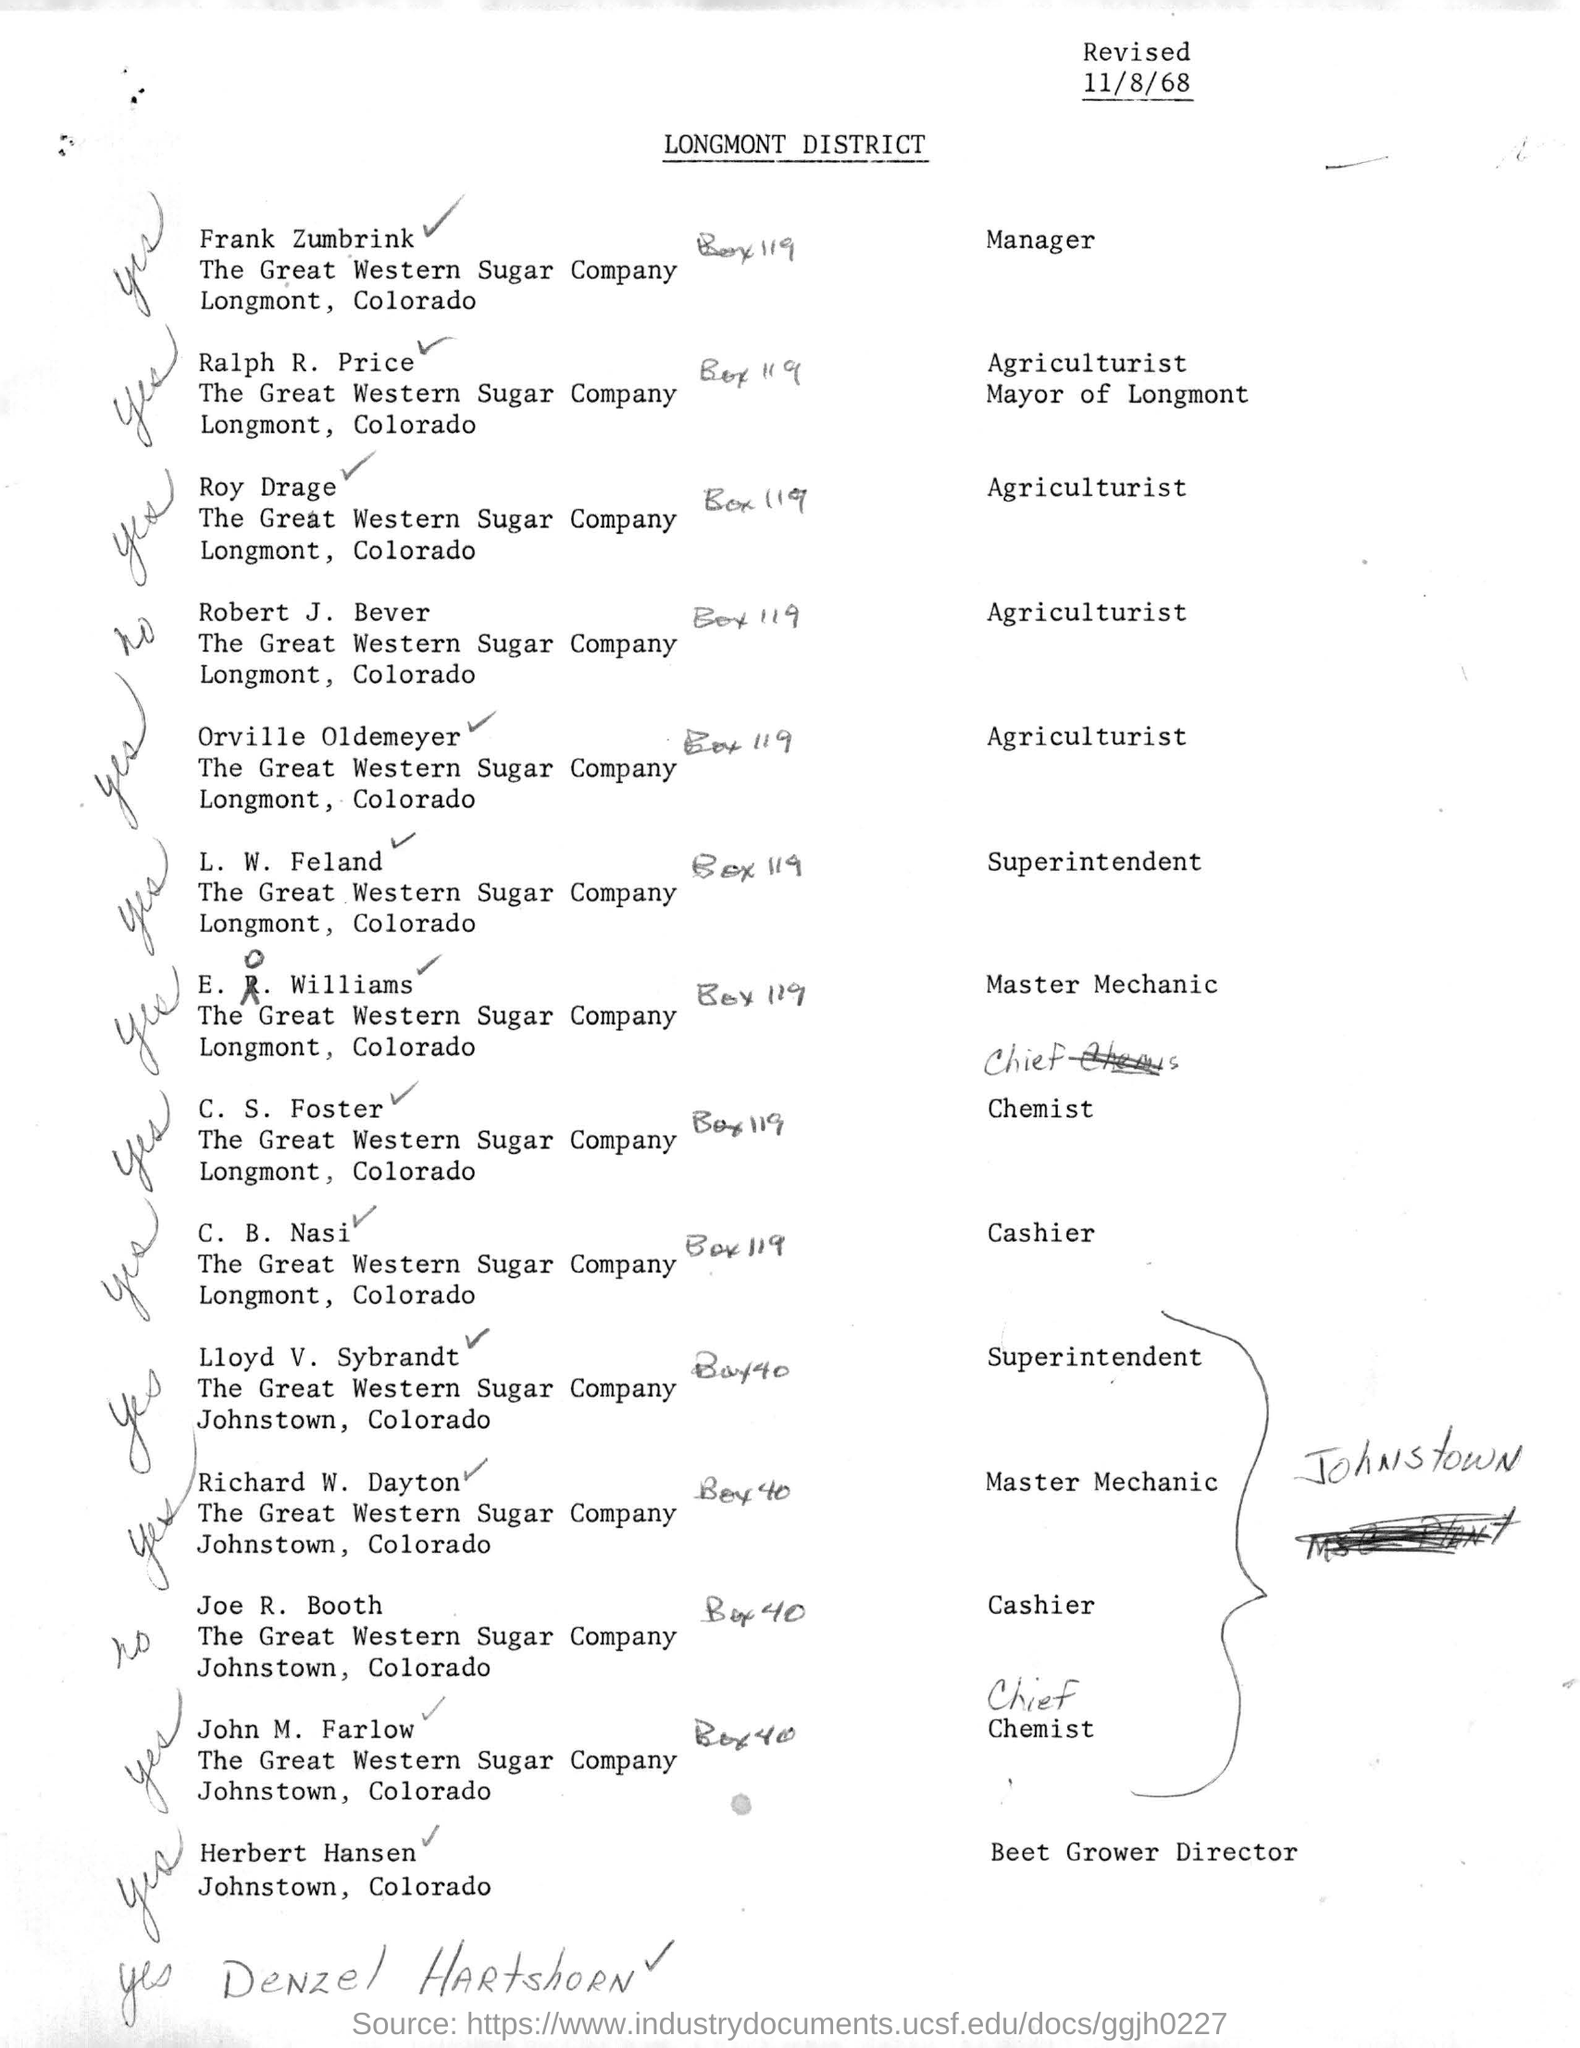When is the document revised?
Give a very brief answer. 11/8/68. Who is the cashier of Longmont, Colorado?
Provide a short and direct response. C. B. Nasi. What is the designation of  l.w. feland?
Provide a succinct answer. Superintendent. 